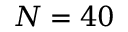<formula> <loc_0><loc_0><loc_500><loc_500>N = 4 0</formula> 